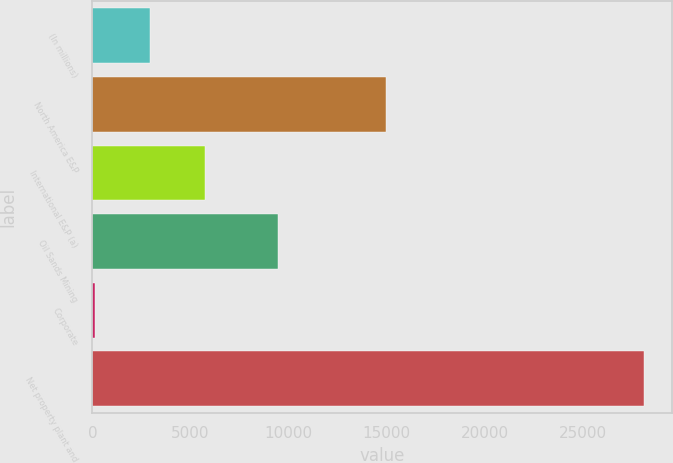Convert chart. <chart><loc_0><loc_0><loc_500><loc_500><bar_chart><fcel>(In millions)<fcel>North America E&P<fcel>International E&P (a)<fcel>Oil Sands Mining<fcel>Corporate<fcel>Net property plant and<nl><fcel>2936<fcel>14973<fcel>5737<fcel>9447<fcel>135<fcel>28145<nl></chart> 